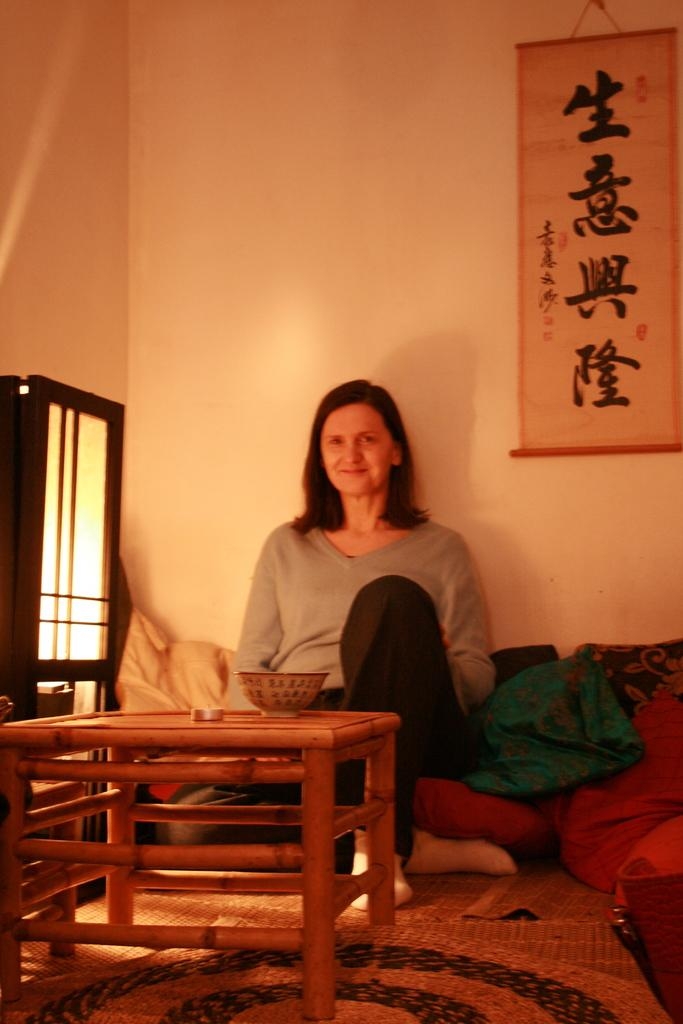Who is present in the image? There is a woman in the image. What is the woman wearing? The woman is wearing black pants. What is the woman sitting on? The woman is sitting on a pillow. What is in front of the woman? There is a table in front of the woman. What is on the table? There is a bowl on the table. Where is the light source in the image? There is a light in the left corner of the image. What type of teeth can be seen in the image? There are no teeth visible in the image, as it features a woman sitting on a pillow with a table and a bowl in front of her. 